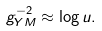<formula> <loc_0><loc_0><loc_500><loc_500>g ^ { - 2 } _ { Y M } \approx \log u .</formula> 